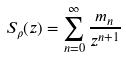Convert formula to latex. <formula><loc_0><loc_0><loc_500><loc_500>S _ { \rho } ( z ) = \sum _ { n = 0 } ^ { \infty } \frac { m _ { n } } { z ^ { n + 1 } }</formula> 